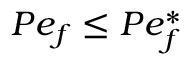Convert formula to latex. <formula><loc_0><loc_0><loc_500><loc_500>P e _ { f } \leq P e _ { f } ^ { \ast }</formula> 